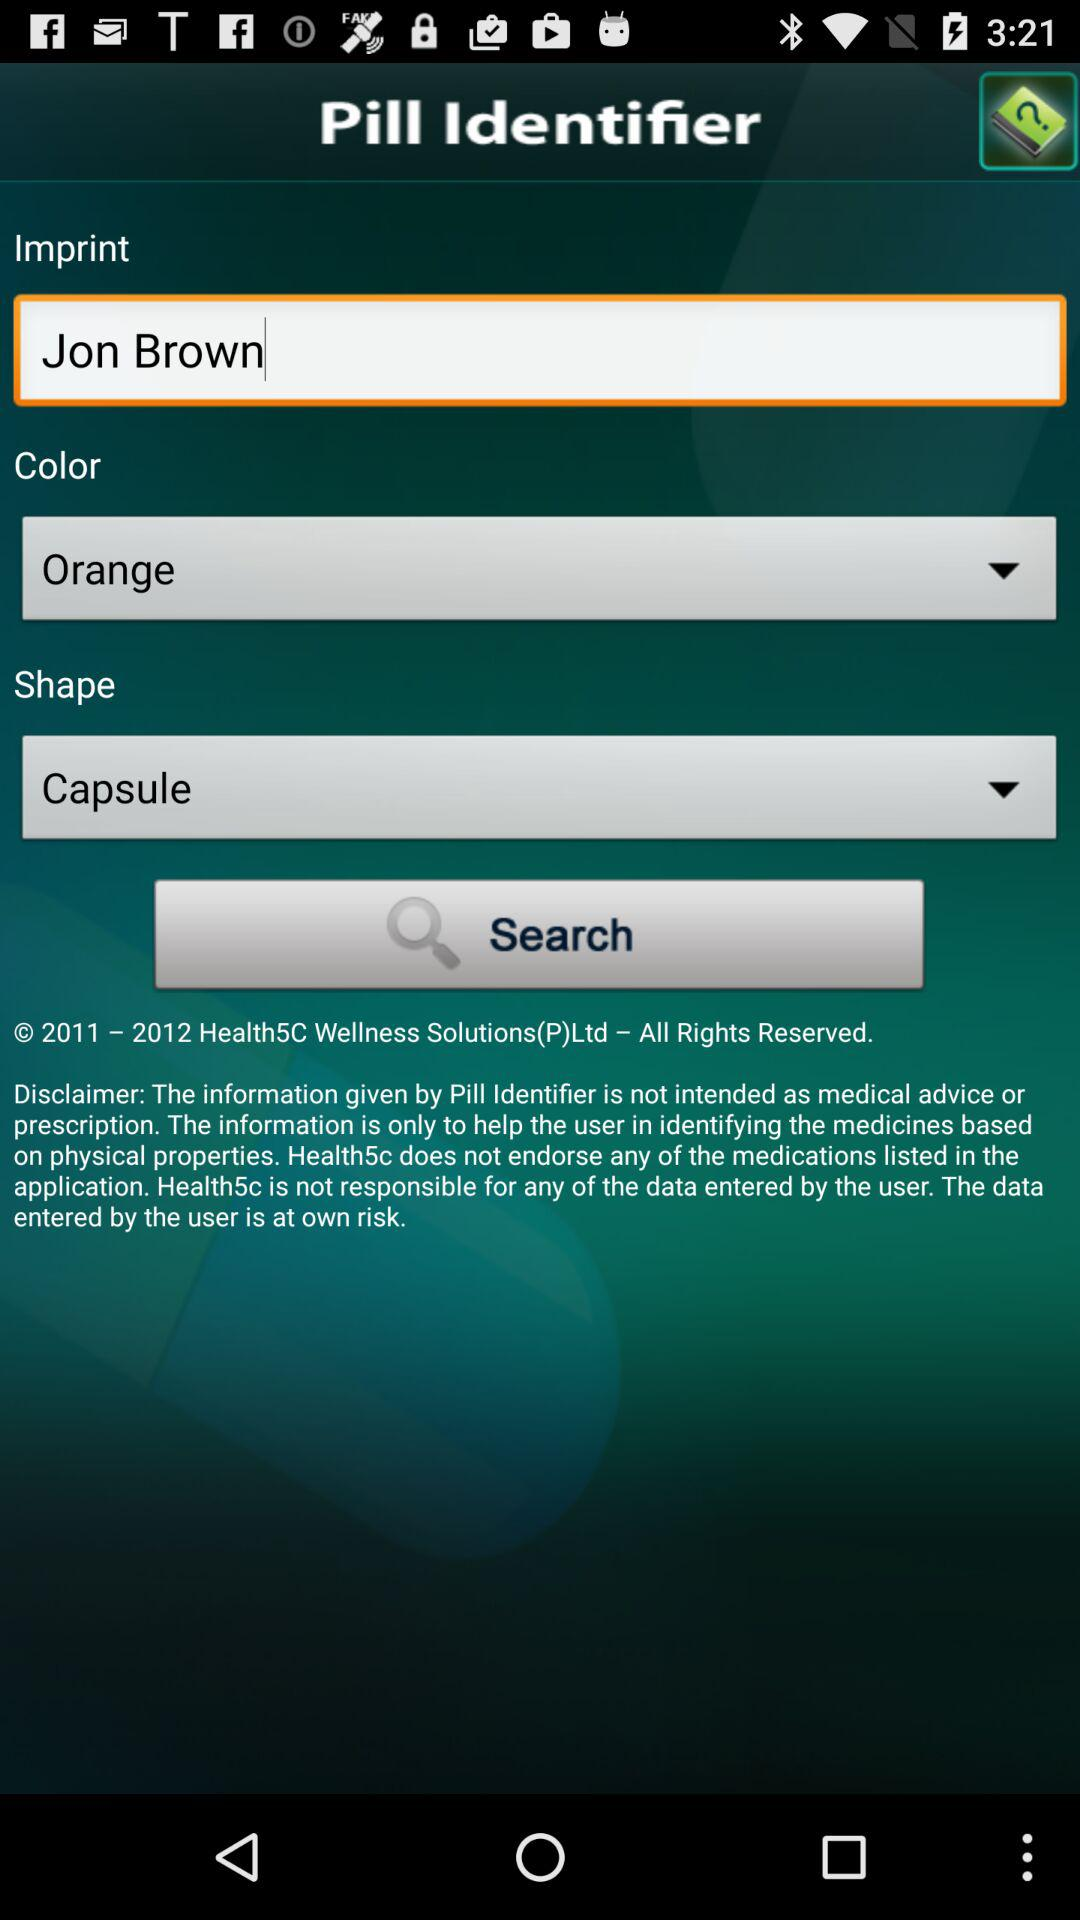What is the entered imprint? The entered imprint is Jon Brown. 